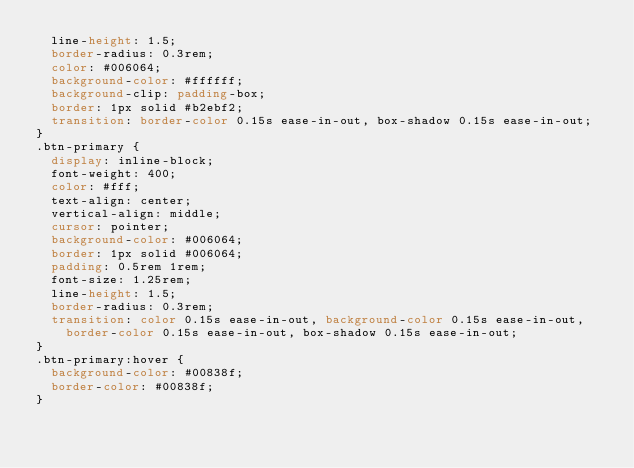<code> <loc_0><loc_0><loc_500><loc_500><_CSS_>  line-height: 1.5;
  border-radius: 0.3rem;
  color: #006064;
  background-color: #ffffff;
  background-clip: padding-box;
  border: 1px solid #b2ebf2;
  transition: border-color 0.15s ease-in-out, box-shadow 0.15s ease-in-out;
}
.btn-primary {
  display: inline-block;
  font-weight: 400;
  color: #fff;
  text-align: center;
  vertical-align: middle;
  cursor: pointer;
  background-color: #006064;
  border: 1px solid #006064;
  padding: 0.5rem 1rem;
  font-size: 1.25rem;
  line-height: 1.5;
  border-radius: 0.3rem;
  transition: color 0.15s ease-in-out, background-color 0.15s ease-in-out,
    border-color 0.15s ease-in-out, box-shadow 0.15s ease-in-out;
}
.btn-primary:hover {
  background-color: #00838f;
  border-color: #00838f;
}
</code> 